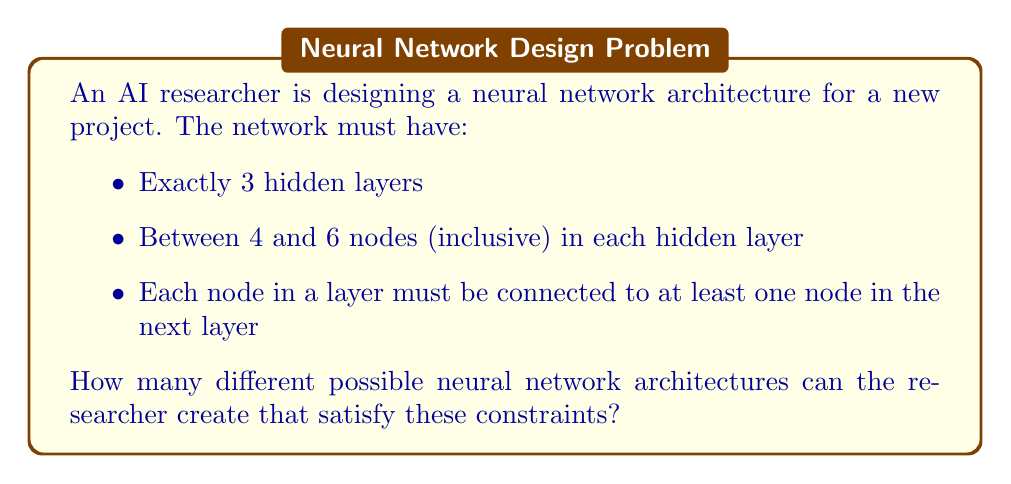Can you solve this math problem? Let's approach this problem step by step:

1) First, we need to determine the number of choices for each hidden layer:
   - Each layer can have 4, 5, or 6 nodes
   - This means there are 3 choices for each of the 3 hidden layers

2) Using the multiplication principle, the total number of ways to choose the number of nodes for all 3 layers is:
   $$ 3 \times 3 \times 3 = 27 $$

3) However, this only accounts for the number of nodes in each layer. We also need to consider the connections between layers.

4) For each pair of adjacent layers, we need to ensure that each node in the first layer is connected to at least one node in the next layer, and each node in the next layer is connected to at least one node in the previous layer.

5) The number of ways to connect two layers depends on the number of nodes in each layer. Let's consider the worst case scenario: 4 nodes in one layer and 6 in the next.

6) In this case, we need to choose at least one connection for each of the 4 nodes in the first layer, and at least one connection for each of the 6 nodes in the second layer. This can be done in many ways, but the minimum number of connections is 6 (connecting each node in the larger layer to at least one node in the smaller layer).

7) The maximum number of connections is when every node in one layer is connected to every node in the next layer: $4 \times 6 = 24$ connections.

8) For each possible connection, we have 2 choices: it's either present or not. However, we need to subtract the configurations where a node has no connections.

9) The total number of ways to connect two layers (in the worst case scenario) is therefore less than:
   $$ 2^{24} - 1 = 16,777,215 $$
   (We subtract 1 to exclude the case where no connections are made)

10) We have two pairs of adjacent layers, so we need to square this number:
    $$ (2^{24} - 1)^2 \approx 2.81 \times 10^{14} $$

11) Finally, we multiply this by the number of ways to choose the number of nodes in each layer:
    $$ 27 \times (2^{24} - 1)^2 \approx 7.59 \times 10^{15} $$

This is an upper bound on the number of possible architectures, as some configurations with more nodes in each layer will have fewer possible connection patterns.
Answer: The researcher can create fewer than $7.59 \times 10^{15}$ different neural network architectures that satisfy the given constraints. 